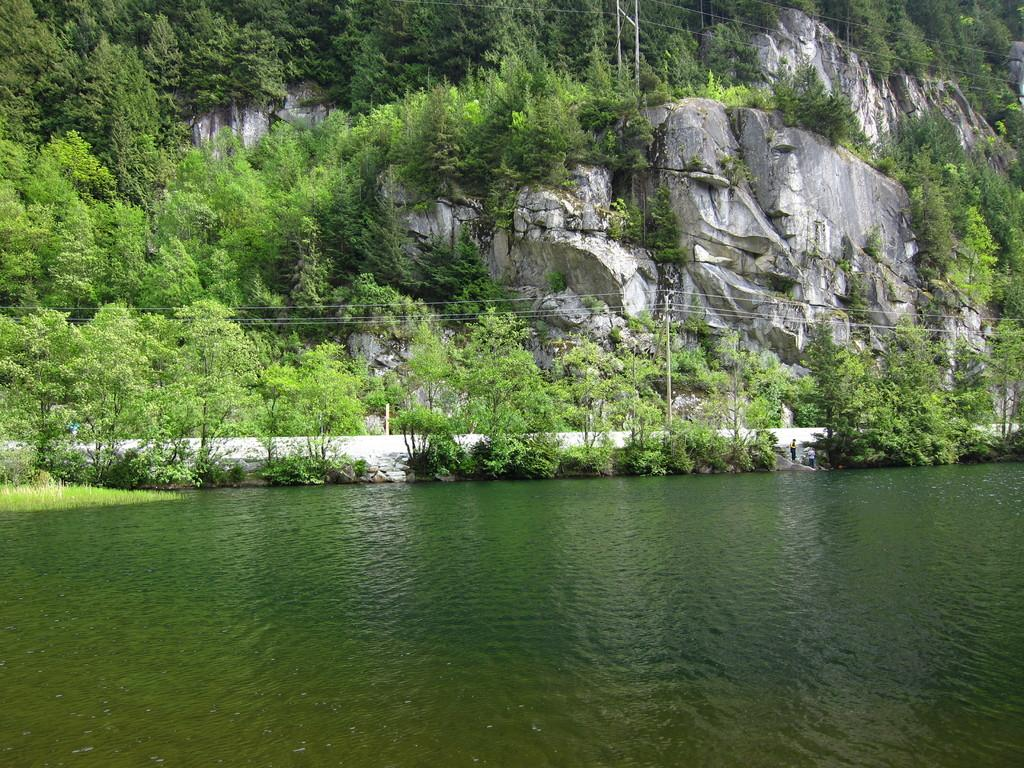What is one of the natural elements visible in the image? There is water in the image. What is another natural element visible in the image? There is grass in the image. What type of man-made structure can be seen in the image? There is a road in the image. What can be seen in the background of the image? There are trees and rocks in the background of the image. What is the purpose of the utility pole in the image? The utility pole in the image is likely used for supporting wires. Can you tell me what type of pen is being used by the doll in the image? There is no doll or pen present in the image. 